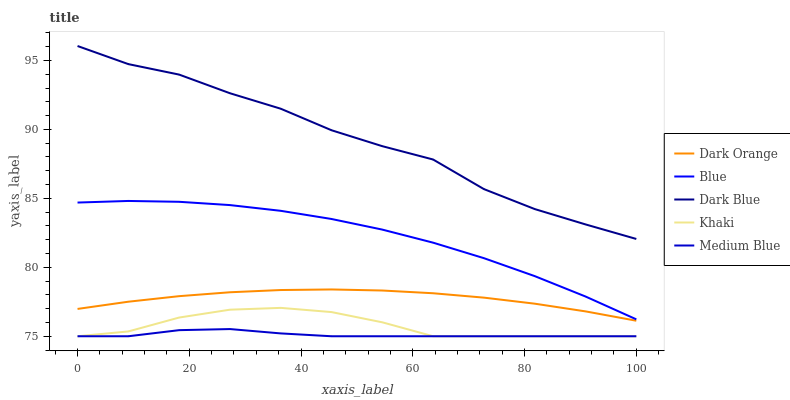Does Dark Orange have the minimum area under the curve?
Answer yes or no. No. Does Dark Orange have the maximum area under the curve?
Answer yes or no. No. Is Khaki the smoothest?
Answer yes or no. No. Is Khaki the roughest?
Answer yes or no. No. Does Dark Orange have the lowest value?
Answer yes or no. No. Does Dark Orange have the highest value?
Answer yes or no. No. Is Dark Orange less than Blue?
Answer yes or no. Yes. Is Dark Blue greater than Dark Orange?
Answer yes or no. Yes. Does Dark Orange intersect Blue?
Answer yes or no. No. 